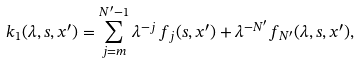<formula> <loc_0><loc_0><loc_500><loc_500>k _ { 1 } ( \lambda , s , x ^ { \prime } ) = \sum _ { j = m } ^ { N ^ { \prime } - 1 } \lambda ^ { - j } \, f _ { j } ( s , x ^ { \prime } ) + \lambda ^ { - N ^ { \prime } } f _ { N ^ { \prime } } ( \lambda , s , x ^ { \prime } ) ,</formula> 